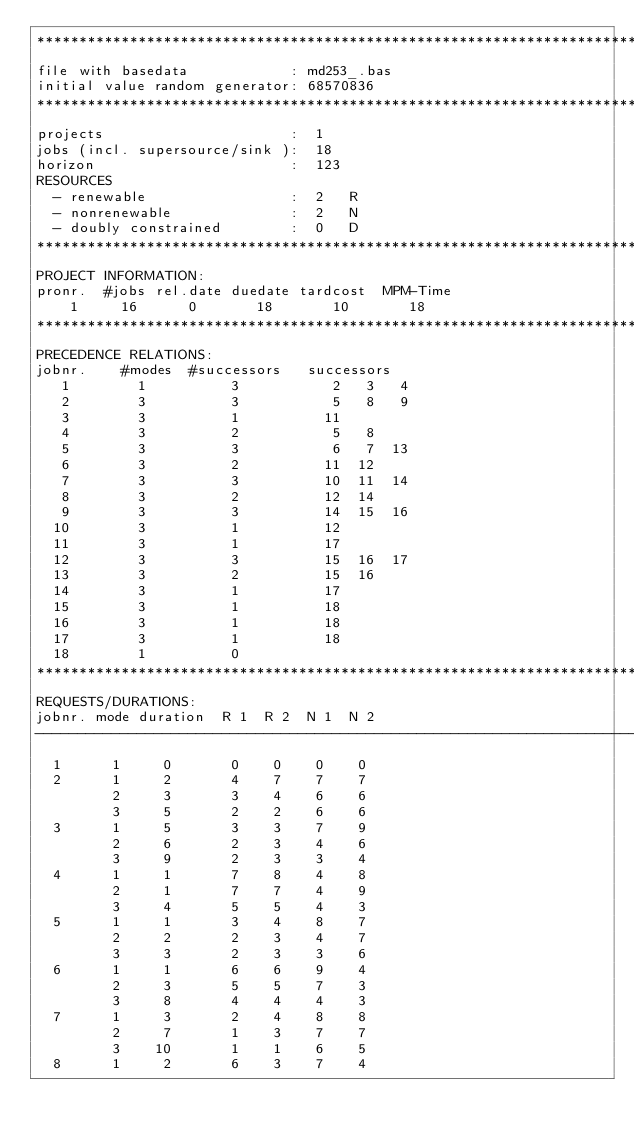<code> <loc_0><loc_0><loc_500><loc_500><_ObjectiveC_>************************************************************************
file with basedata            : md253_.bas
initial value random generator: 68570836
************************************************************************
projects                      :  1
jobs (incl. supersource/sink ):  18
horizon                       :  123
RESOURCES
  - renewable                 :  2   R
  - nonrenewable              :  2   N
  - doubly constrained        :  0   D
************************************************************************
PROJECT INFORMATION:
pronr.  #jobs rel.date duedate tardcost  MPM-Time
    1     16      0       18       10       18
************************************************************************
PRECEDENCE RELATIONS:
jobnr.    #modes  #successors   successors
   1        1          3           2   3   4
   2        3          3           5   8   9
   3        3          1          11
   4        3          2           5   8
   5        3          3           6   7  13
   6        3          2          11  12
   7        3          3          10  11  14
   8        3          2          12  14
   9        3          3          14  15  16
  10        3          1          12
  11        3          1          17
  12        3          3          15  16  17
  13        3          2          15  16
  14        3          1          17
  15        3          1          18
  16        3          1          18
  17        3          1          18
  18        1          0        
************************************************************************
REQUESTS/DURATIONS:
jobnr. mode duration  R 1  R 2  N 1  N 2
------------------------------------------------------------------------
  1      1     0       0    0    0    0
  2      1     2       4    7    7    7
         2     3       3    4    6    6
         3     5       2    2    6    6
  3      1     5       3    3    7    9
         2     6       2    3    4    6
         3     9       2    3    3    4
  4      1     1       7    8    4    8
         2     1       7    7    4    9
         3     4       5    5    4    3
  5      1     1       3    4    8    7
         2     2       2    3    4    7
         3     3       2    3    3    6
  6      1     1       6    6    9    4
         2     3       5    5    7    3
         3     8       4    4    4    3
  7      1     3       2    4    8    8
         2     7       1    3    7    7
         3    10       1    1    6    5
  8      1     2       6    3    7    4</code> 